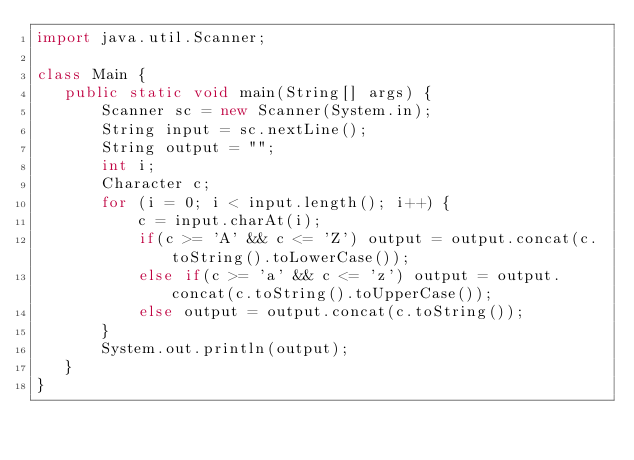<code> <loc_0><loc_0><loc_500><loc_500><_Java_>import java.util.Scanner;

class Main {
   public static void main(String[] args) {
       Scanner sc = new Scanner(System.in);
       String input = sc.nextLine();
       String output = "";
       int i;
       Character c;
       for (i = 0; i < input.length(); i++) {
           c = input.charAt(i);
           if(c >= 'A' && c <= 'Z') output = output.concat(c.toString().toLowerCase());
           else if(c >= 'a' && c <= 'z') output = output.concat(c.toString().toUpperCase());
           else output = output.concat(c.toString());
       }
       System.out.println(output);
   }
}
</code> 